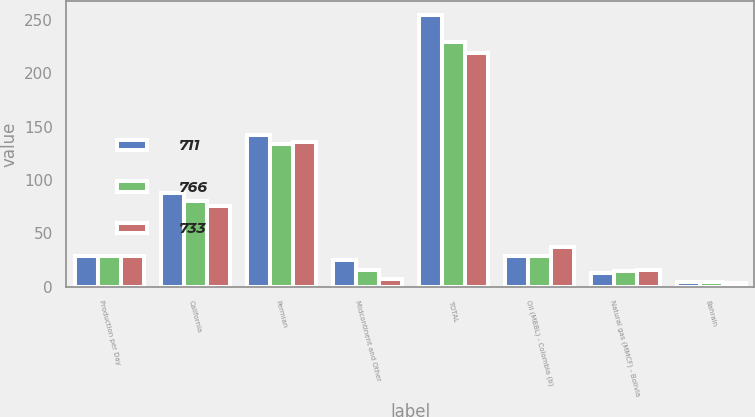Convert chart. <chart><loc_0><loc_0><loc_500><loc_500><stacked_bar_chart><ecel><fcel>Production per Day<fcel>California<fcel>Permian<fcel>Midcontinent and Other<fcel>TOTAL<fcel>Oil (MBBL) - Colombia (b)<fcel>Natural gas (MMCF) - Bolivia<fcel>Bahrain<nl><fcel>711<fcel>29<fcel>88<fcel>142<fcel>25<fcel>255<fcel>29<fcel>13<fcel>4<nl><fcel>766<fcel>29<fcel>80<fcel>134<fcel>16<fcel>230<fcel>29<fcel>15<fcel>4<nl><fcel>733<fcel>29<fcel>76<fcel>136<fcel>7<fcel>219<fcel>37<fcel>16<fcel>3<nl></chart> 